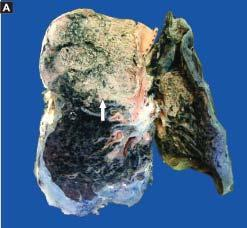re these layers rest lying separated from the septal walls by a clear space?
Answer the question using a single word or phrase. No 